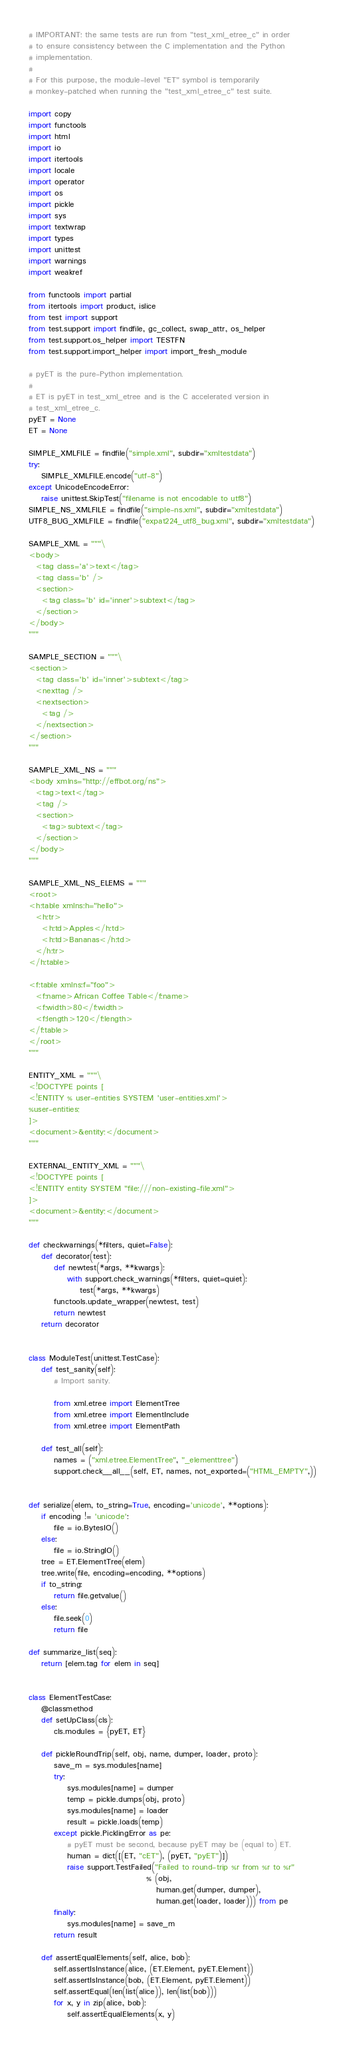<code> <loc_0><loc_0><loc_500><loc_500><_Python_># IMPORTANT: the same tests are run from "test_xml_etree_c" in order
# to ensure consistency between the C implementation and the Python
# implementation.
#
# For this purpose, the module-level "ET" symbol is temporarily
# monkey-patched when running the "test_xml_etree_c" test suite.

import copy
import functools
import html
import io
import itertools
import locale
import operator
import os
import pickle
import sys
import textwrap
import types
import unittest
import warnings
import weakref

from functools import partial
from itertools import product, islice
from test import support
from test.support import findfile, gc_collect, swap_attr, os_helper
from test.support.os_helper import TESTFN
from test.support.import_helper import import_fresh_module

# pyET is the pure-Python implementation.
#
# ET is pyET in test_xml_etree and is the C accelerated version in
# test_xml_etree_c.
pyET = None
ET = None

SIMPLE_XMLFILE = findfile("simple.xml", subdir="xmltestdata")
try:
    SIMPLE_XMLFILE.encode("utf-8")
except UnicodeEncodeError:
    raise unittest.SkipTest("filename is not encodable to utf8")
SIMPLE_NS_XMLFILE = findfile("simple-ns.xml", subdir="xmltestdata")
UTF8_BUG_XMLFILE = findfile("expat224_utf8_bug.xml", subdir="xmltestdata")

SAMPLE_XML = """\
<body>
  <tag class='a'>text</tag>
  <tag class='b' />
  <section>
    <tag class='b' id='inner'>subtext</tag>
  </section>
</body>
"""

SAMPLE_SECTION = """\
<section>
  <tag class='b' id='inner'>subtext</tag>
  <nexttag />
  <nextsection>
    <tag />
  </nextsection>
</section>
"""

SAMPLE_XML_NS = """
<body xmlns="http://effbot.org/ns">
  <tag>text</tag>
  <tag />
  <section>
    <tag>subtext</tag>
  </section>
</body>
"""

SAMPLE_XML_NS_ELEMS = """
<root>
<h:table xmlns:h="hello">
  <h:tr>
    <h:td>Apples</h:td>
    <h:td>Bananas</h:td>
  </h:tr>
</h:table>

<f:table xmlns:f="foo">
  <f:name>African Coffee Table</f:name>
  <f:width>80</f:width>
  <f:length>120</f:length>
</f:table>
</root>
"""

ENTITY_XML = """\
<!DOCTYPE points [
<!ENTITY % user-entities SYSTEM 'user-entities.xml'>
%user-entities;
]>
<document>&entity;</document>
"""

EXTERNAL_ENTITY_XML = """\
<!DOCTYPE points [
<!ENTITY entity SYSTEM "file:///non-existing-file.xml">
]>
<document>&entity;</document>
"""

def checkwarnings(*filters, quiet=False):
    def decorator(test):
        def newtest(*args, **kwargs):
            with support.check_warnings(*filters, quiet=quiet):
                test(*args, **kwargs)
        functools.update_wrapper(newtest, test)
        return newtest
    return decorator


class ModuleTest(unittest.TestCase):
    def test_sanity(self):
        # Import sanity.

        from xml.etree import ElementTree
        from xml.etree import ElementInclude
        from xml.etree import ElementPath

    def test_all(self):
        names = ("xml.etree.ElementTree", "_elementtree")
        support.check__all__(self, ET, names, not_exported=("HTML_EMPTY",))


def serialize(elem, to_string=True, encoding='unicode', **options):
    if encoding != 'unicode':
        file = io.BytesIO()
    else:
        file = io.StringIO()
    tree = ET.ElementTree(elem)
    tree.write(file, encoding=encoding, **options)
    if to_string:
        return file.getvalue()
    else:
        file.seek(0)
        return file

def summarize_list(seq):
    return [elem.tag for elem in seq]


class ElementTestCase:
    @classmethod
    def setUpClass(cls):
        cls.modules = {pyET, ET}

    def pickleRoundTrip(self, obj, name, dumper, loader, proto):
        save_m = sys.modules[name]
        try:
            sys.modules[name] = dumper
            temp = pickle.dumps(obj, proto)
            sys.modules[name] = loader
            result = pickle.loads(temp)
        except pickle.PicklingError as pe:
            # pyET must be second, because pyET may be (equal to) ET.
            human = dict([(ET, "cET"), (pyET, "pyET")])
            raise support.TestFailed("Failed to round-trip %r from %r to %r"
                                     % (obj,
                                        human.get(dumper, dumper),
                                        human.get(loader, loader))) from pe
        finally:
            sys.modules[name] = save_m
        return result

    def assertEqualElements(self, alice, bob):
        self.assertIsInstance(alice, (ET.Element, pyET.Element))
        self.assertIsInstance(bob, (ET.Element, pyET.Element))
        self.assertEqual(len(list(alice)), len(list(bob)))
        for x, y in zip(alice, bob):
            self.assertEqualElements(x, y)</code> 